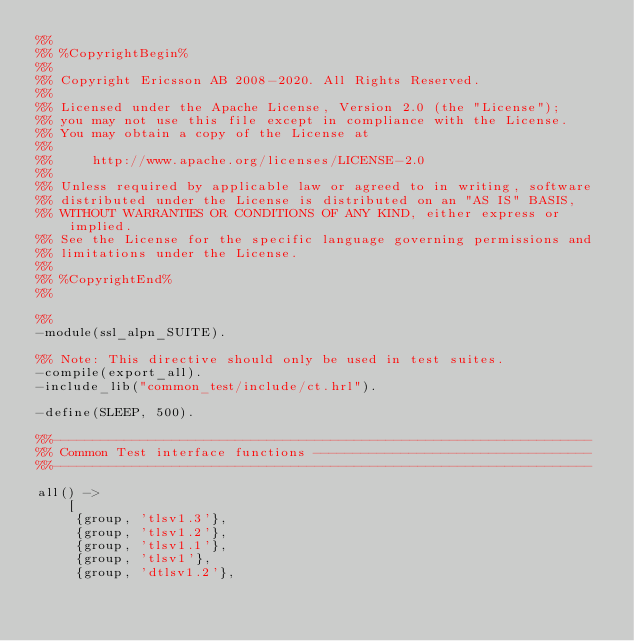<code> <loc_0><loc_0><loc_500><loc_500><_Erlang_>%%
%% %CopyrightBegin%
%%
%% Copyright Ericsson AB 2008-2020. All Rights Reserved.
%%
%% Licensed under the Apache License, Version 2.0 (the "License");
%% you may not use this file except in compliance with the License.
%% You may obtain a copy of the License at
%%
%%     http://www.apache.org/licenses/LICENSE-2.0
%%
%% Unless required by applicable law or agreed to in writing, software
%% distributed under the License is distributed on an "AS IS" BASIS,
%% WITHOUT WARRANTIES OR CONDITIONS OF ANY KIND, either express or implied.
%% See the License for the specific language governing permissions and
%% limitations under the License.
%%
%% %CopyrightEnd%
%%

%%
-module(ssl_alpn_SUITE).

%% Note: This directive should only be used in test suites.
-compile(export_all).
-include_lib("common_test/include/ct.hrl").

-define(SLEEP, 500).

%%--------------------------------------------------------------------
%% Common Test interface functions -----------------------------------
%%--------------------------------------------------------------------

all() ->
    [
     {group, 'tlsv1.3'},
     {group, 'tlsv1.2'},
     {group, 'tlsv1.1'},
     {group, 'tlsv1'},
     {group, 'dtlsv1.2'},</code> 